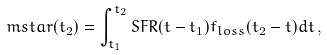<formula> <loc_0><loc_0><loc_500><loc_500>\ m s t a r ( t _ { 2 } ) = \int _ { t _ { 1 } } ^ { t _ { 2 } } S F R ( t - t _ { 1 } ) f _ { l o s s } ( t _ { 2 } - t ) d t \, ,</formula> 